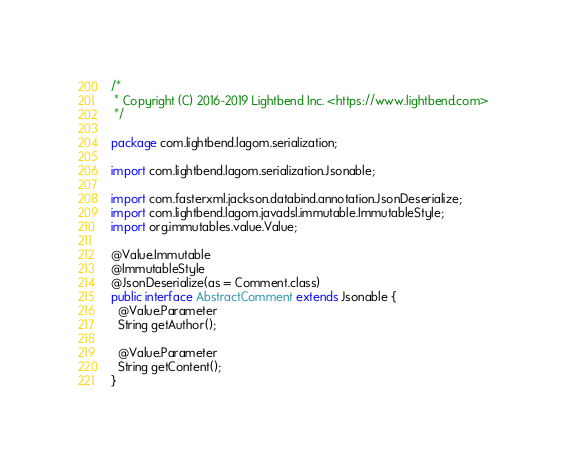Convert code to text. <code><loc_0><loc_0><loc_500><loc_500><_Java_>/*
 * Copyright (C) 2016-2019 Lightbend Inc. <https://www.lightbend.com>
 */

package com.lightbend.lagom.serialization;

import com.lightbend.lagom.serialization.Jsonable;

import com.fasterxml.jackson.databind.annotation.JsonDeserialize;
import com.lightbend.lagom.javadsl.immutable.ImmutableStyle;
import org.immutables.value.Value;

@Value.Immutable
@ImmutableStyle
@JsonDeserialize(as = Comment.class)
public interface AbstractComment extends Jsonable {
  @Value.Parameter
  String getAuthor();

  @Value.Parameter
  String getContent();
}
</code> 